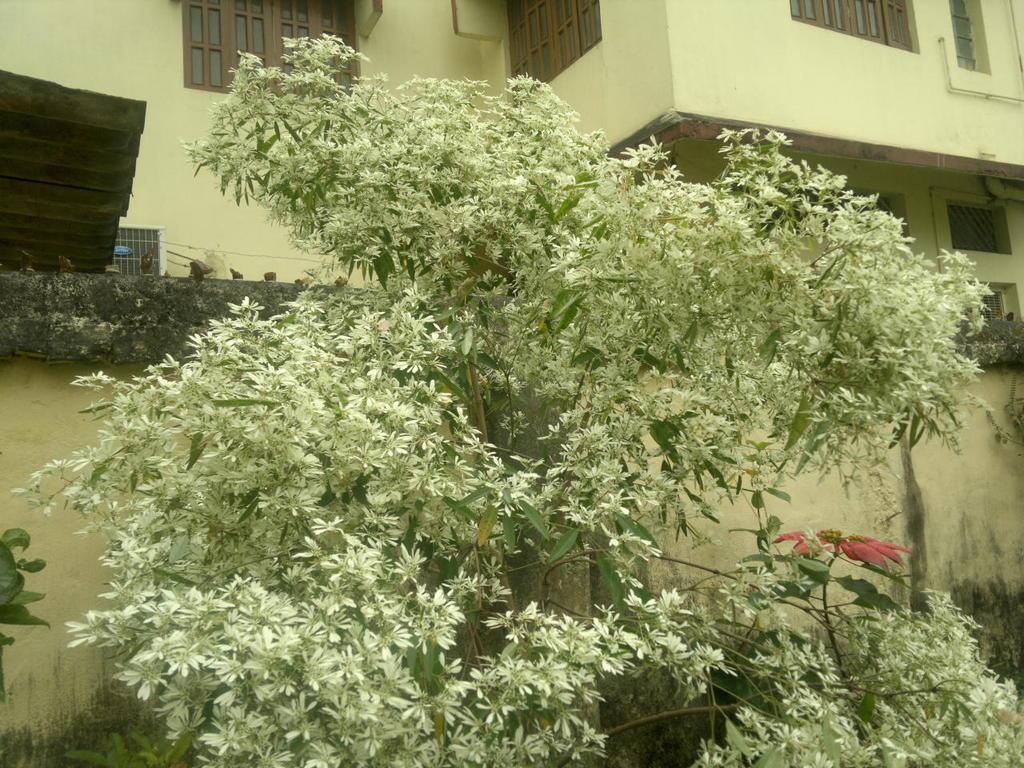Could you give a brief overview of what you see in this image? In this image we can see trees and plants. In the background of the image there is a wall, building and other objects. 